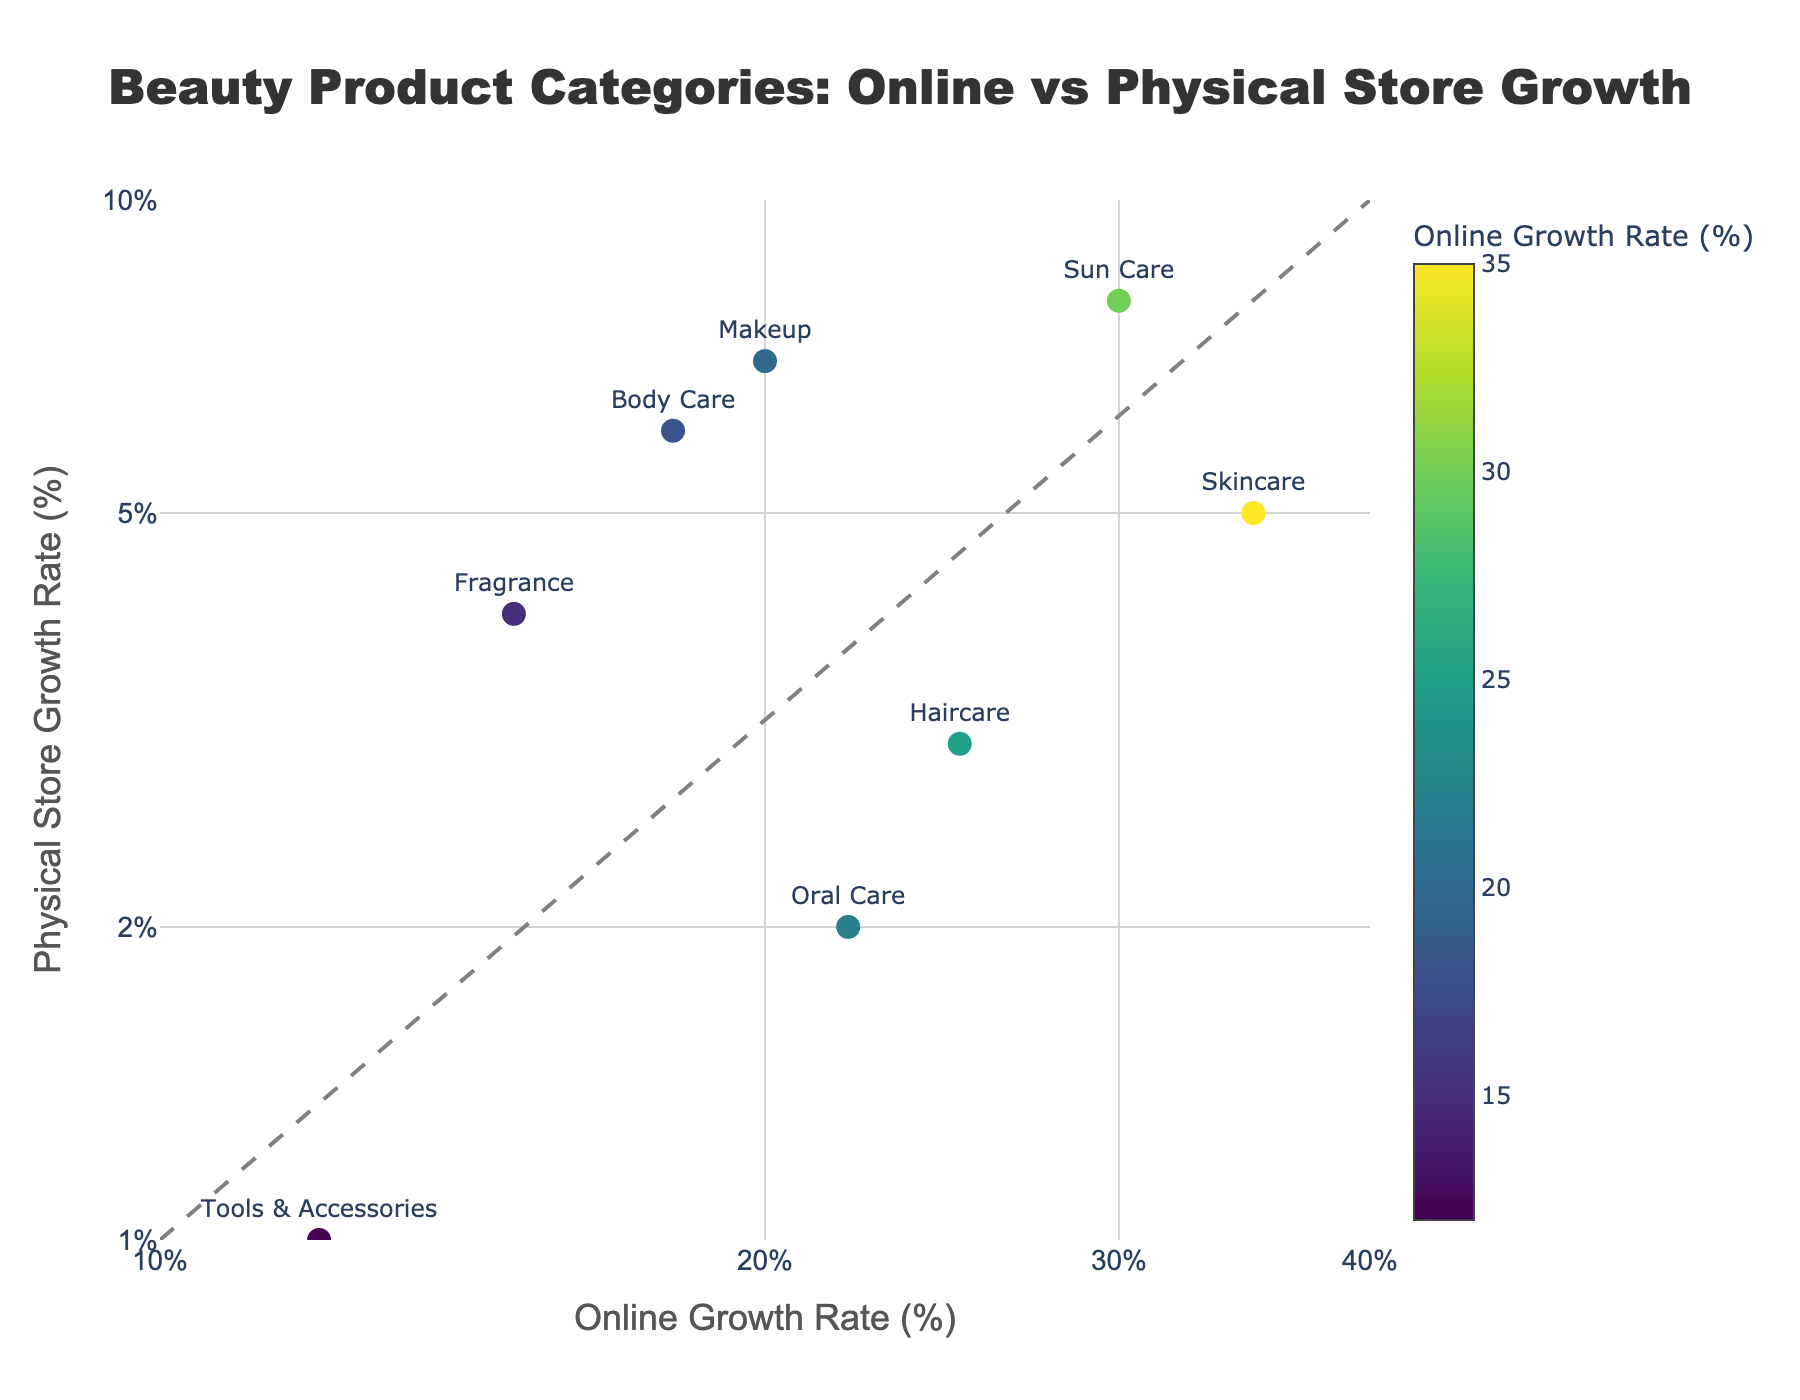What is the title of the scatter plot? The title is usually placed at the top of the plot and describes the main focus of the data being visualized. In this case, it provides context about the data shown in the scatter plot.
Answer: Beauty Product Categories: Online vs Physical Store Growth What are the axes titles of the scatter plot? Axes titles typically describe the data represented on each axis. They are usually located along the horizontal (x) and vertical (y) axes.
Answer: Online Growth Rate (%) (x-axis), Physical Store Growth Rate (%) (y-axis) How many data points are shown in the scatter plot? By counting the number of markers or points on the plot, we can determine the quantity of data points. Each marker corresponds to one category.
Answer: 8 Which category has the highest online growth rate? Look for the marker placed farthest to the right on the horizontal axis labeled "Online Growth Rate (%)". The text label next to this marker is the category with the highest online growth rate.
Answer: Skincare Which categories exhibit growth rates for physical stores of more than 5%? Check the vertical position of each marker. Categories with markers placed above the 5% mark on the "Physical Store Growth Rate (%)" axis are the ones we need to identify.
Answer: Makeup, Body Care, Sun Care What is the online growth rate of the Haircare category? Locate the marker associated with the Haircare category by finding its label. Check its position on the x-axis to determine the online growth rate.
Answer: 25% What is the difference in physical store growth rates between Sun Care and Fragrance categories? Identify the physical store growth rates for both categories from their y-axis positions. Subtract the lower rate from the higher rate to find the difference.
Answer: 8% - 4% = 4% Which categories lie on or above the "Equal growth line"? Observe the diagonal line added to the plot. Any markers lying directly on this line or above it represent categories with greater or equal growth rates online compared to physical stores.
Answer: Makeup, Sun Care Are there any categories with almost equal growth rates online and in physical stores? Check for any markers that are placed very close to or on the diagonal "Equal growth line". These points indicate almost equal growth rates in both online and physical stores.
Answer: None What is the average online growth rate for Body Care and Oral Care categories? Identify the online growth rates for Body Care and Oral Care from the x-axis. Sum these rates and divide by 2 to find the average.
Answer: (18% + 22%) / 2 = 20% 